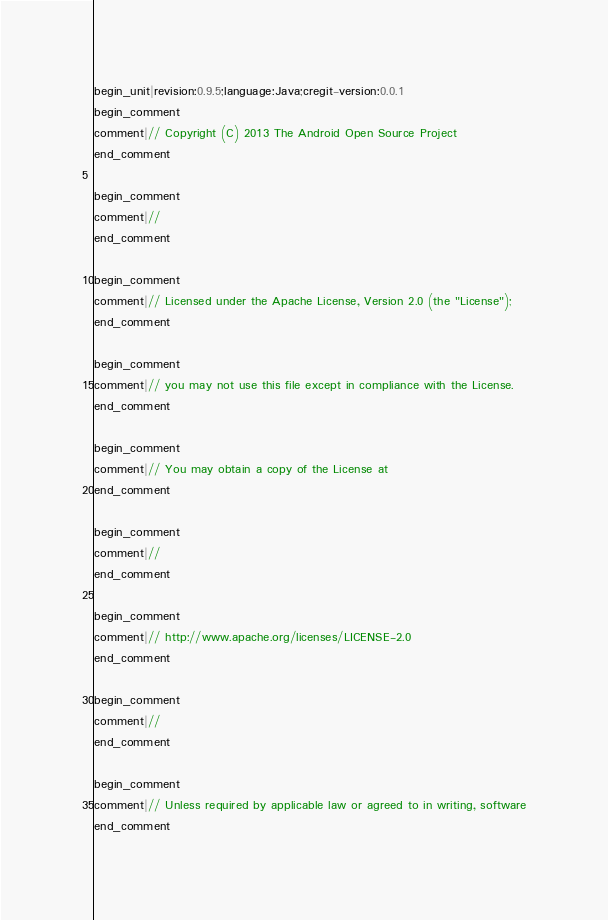<code> <loc_0><loc_0><loc_500><loc_500><_Java_>begin_unit|revision:0.9.5;language:Java;cregit-version:0.0.1
begin_comment
comment|// Copyright (C) 2013 The Android Open Source Project
end_comment

begin_comment
comment|//
end_comment

begin_comment
comment|// Licensed under the Apache License, Version 2.0 (the "License");
end_comment

begin_comment
comment|// you may not use this file except in compliance with the License.
end_comment

begin_comment
comment|// You may obtain a copy of the License at
end_comment

begin_comment
comment|//
end_comment

begin_comment
comment|// http://www.apache.org/licenses/LICENSE-2.0
end_comment

begin_comment
comment|//
end_comment

begin_comment
comment|// Unless required by applicable law or agreed to in writing, software
end_comment
</code> 